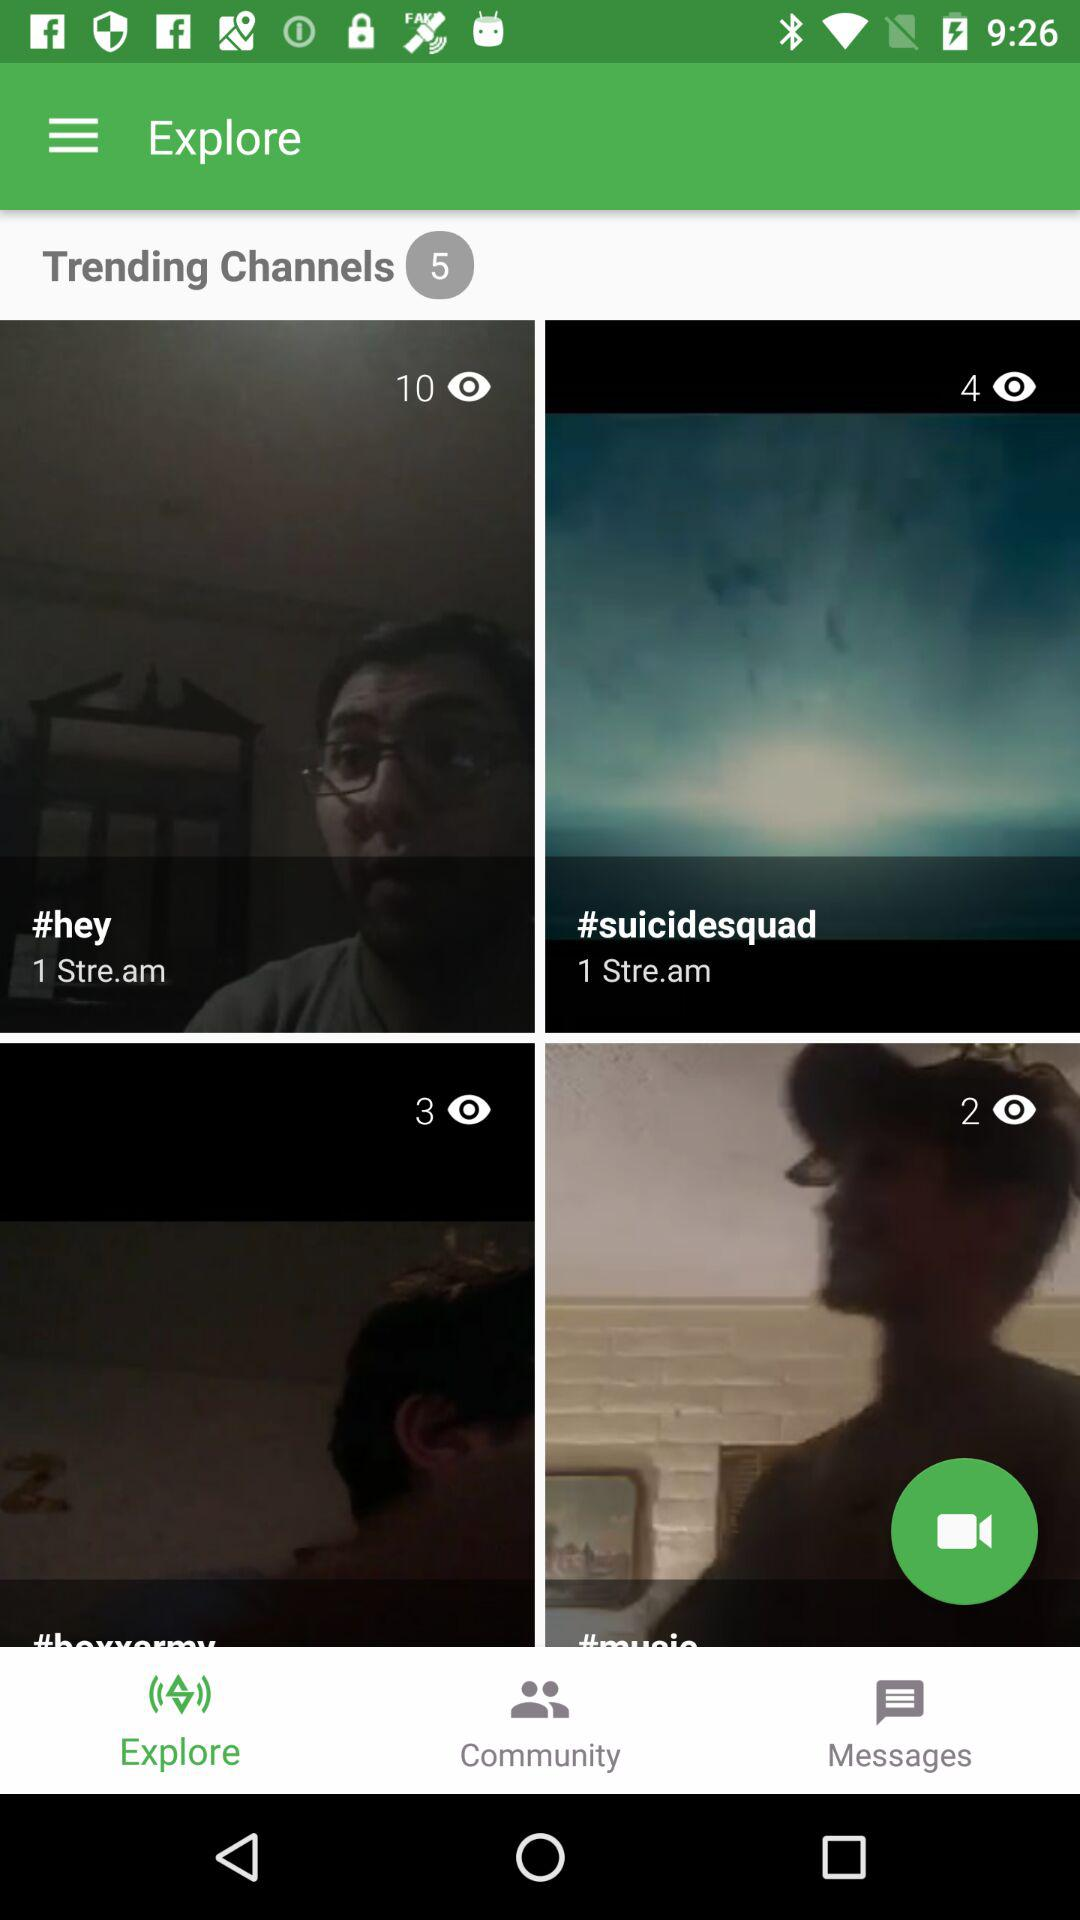How many trending channels are there? There are 5 trending channels. 